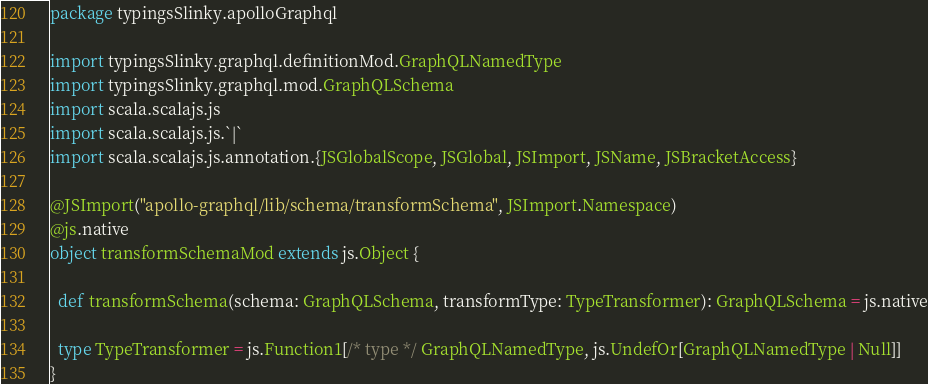<code> <loc_0><loc_0><loc_500><loc_500><_Scala_>package typingsSlinky.apolloGraphql

import typingsSlinky.graphql.definitionMod.GraphQLNamedType
import typingsSlinky.graphql.mod.GraphQLSchema
import scala.scalajs.js
import scala.scalajs.js.`|`
import scala.scalajs.js.annotation.{JSGlobalScope, JSGlobal, JSImport, JSName, JSBracketAccess}

@JSImport("apollo-graphql/lib/schema/transformSchema", JSImport.Namespace)
@js.native
object transformSchemaMod extends js.Object {
  
  def transformSchema(schema: GraphQLSchema, transformType: TypeTransformer): GraphQLSchema = js.native
  
  type TypeTransformer = js.Function1[/* type */ GraphQLNamedType, js.UndefOr[GraphQLNamedType | Null]]
}
</code> 